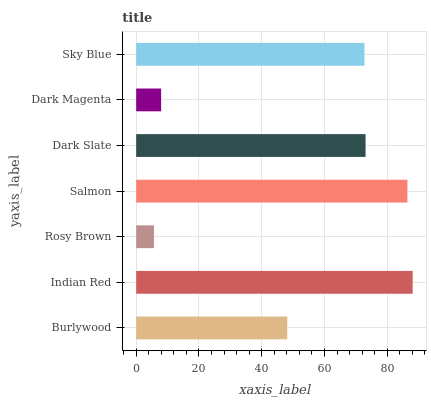Is Rosy Brown the minimum?
Answer yes or no. Yes. Is Indian Red the maximum?
Answer yes or no. Yes. Is Indian Red the minimum?
Answer yes or no. No. Is Rosy Brown the maximum?
Answer yes or no. No. Is Indian Red greater than Rosy Brown?
Answer yes or no. Yes. Is Rosy Brown less than Indian Red?
Answer yes or no. Yes. Is Rosy Brown greater than Indian Red?
Answer yes or no. No. Is Indian Red less than Rosy Brown?
Answer yes or no. No. Is Sky Blue the high median?
Answer yes or no. Yes. Is Sky Blue the low median?
Answer yes or no. Yes. Is Rosy Brown the high median?
Answer yes or no. No. Is Dark Magenta the low median?
Answer yes or no. No. 